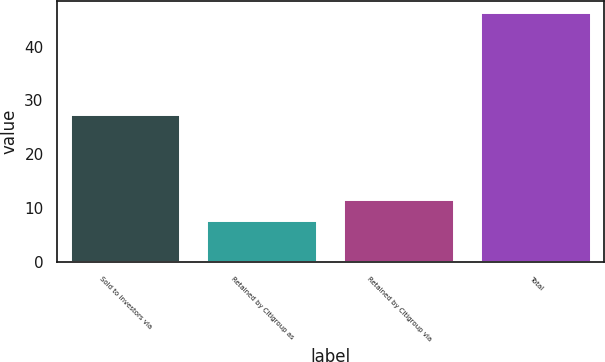Convert chart. <chart><loc_0><loc_0><loc_500><loc_500><bar_chart><fcel>Sold to investors via<fcel>Retained by Citigroup as<fcel>Retained by Citigroup via<fcel>Total<nl><fcel>27.3<fcel>7.6<fcel>11.46<fcel>46.2<nl></chart> 